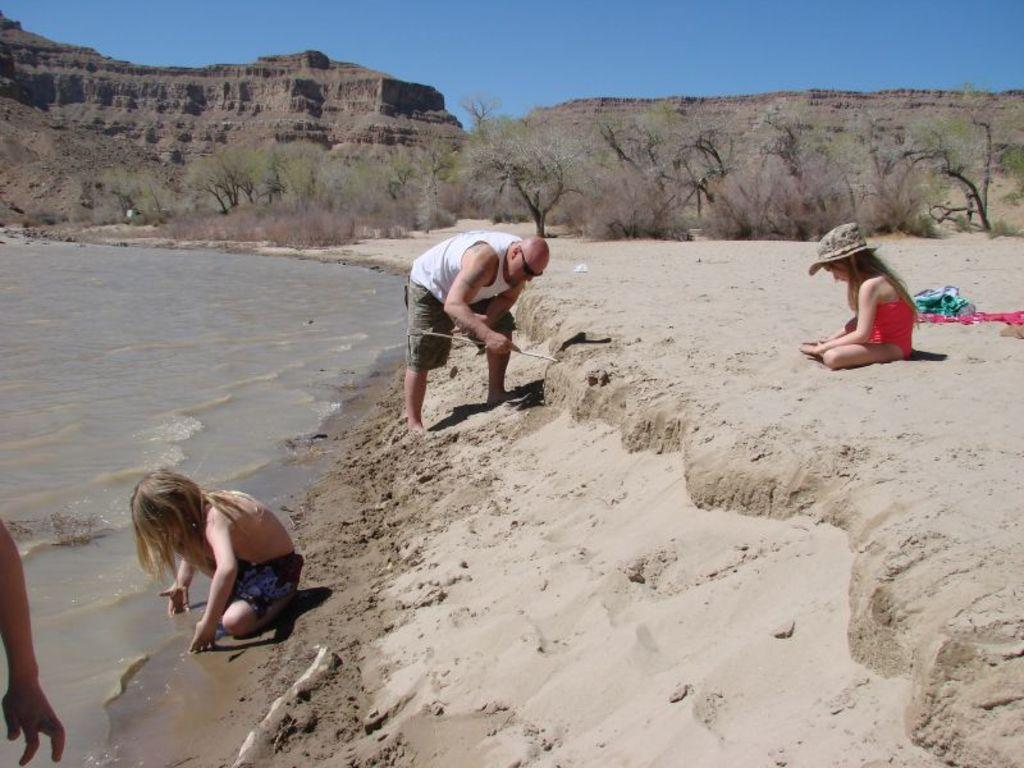What is visible at the top of the image? The sky is visible at the top of the image. What type of landscape feature can be seen in the image? There are hills in the image. What type of vegetation is present in the image? Trees are present in the image. What body of water is at the bottom of the image? There is a lake at the bottom of the image. What are the persons in the image doing? The persons are on the bed of the lake. What type of treatment is being administered to the lake in the image? There is no treatment being administered to the lake in the image; it is a natural body of water. Can you tell me how many earthquakes occurred in the image? There is no indication of an earthquake in the image; it features a lake with persons on its bed. 